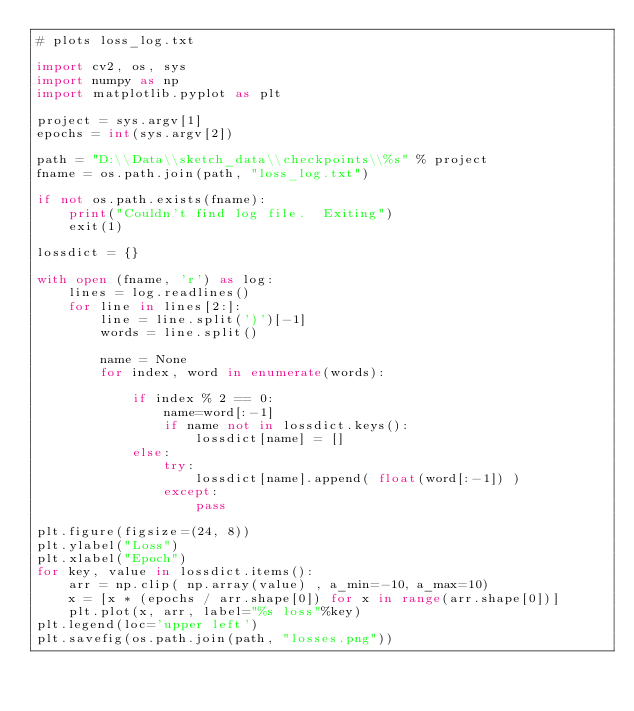Convert code to text. <code><loc_0><loc_0><loc_500><loc_500><_Python_># plots loss_log.txt

import cv2, os, sys
import numpy as np
import matplotlib.pyplot as plt

project = sys.argv[1]
epochs = int(sys.argv[2])

path = "D:\\Data\\sketch_data\\checkpoints\\%s" % project
fname = os.path.join(path, "loss_log.txt")

if not os.path.exists(fname):
    print("Couldn't find log file.  Exiting")
    exit(1)
    
lossdict = {}

with open (fname, 'r') as log:
    lines = log.readlines()
    for line in lines[2:]:
        line = line.split(')')[-1]
        words = line.split()
        
        name = None
        for index, word in enumerate(words):
            
            if index % 2 == 0:
                name=word[:-1]
                if name not in lossdict.keys():
                    lossdict[name] = []
            else:
                try:
                    lossdict[name].append( float(word[:-1]) )
                except:
                    pass

plt.figure(figsize=(24, 8))
plt.ylabel("Loss")
plt.xlabel("Epoch")
for key, value in lossdict.items():
    arr = np.clip( np.array(value) , a_min=-10, a_max=10)
    x = [x * (epochs / arr.shape[0]) for x in range(arr.shape[0])]
    plt.plot(x, arr, label="%s loss"%key)
plt.legend(loc='upper left')
plt.savefig(os.path.join(path, "losses.png"))</code> 